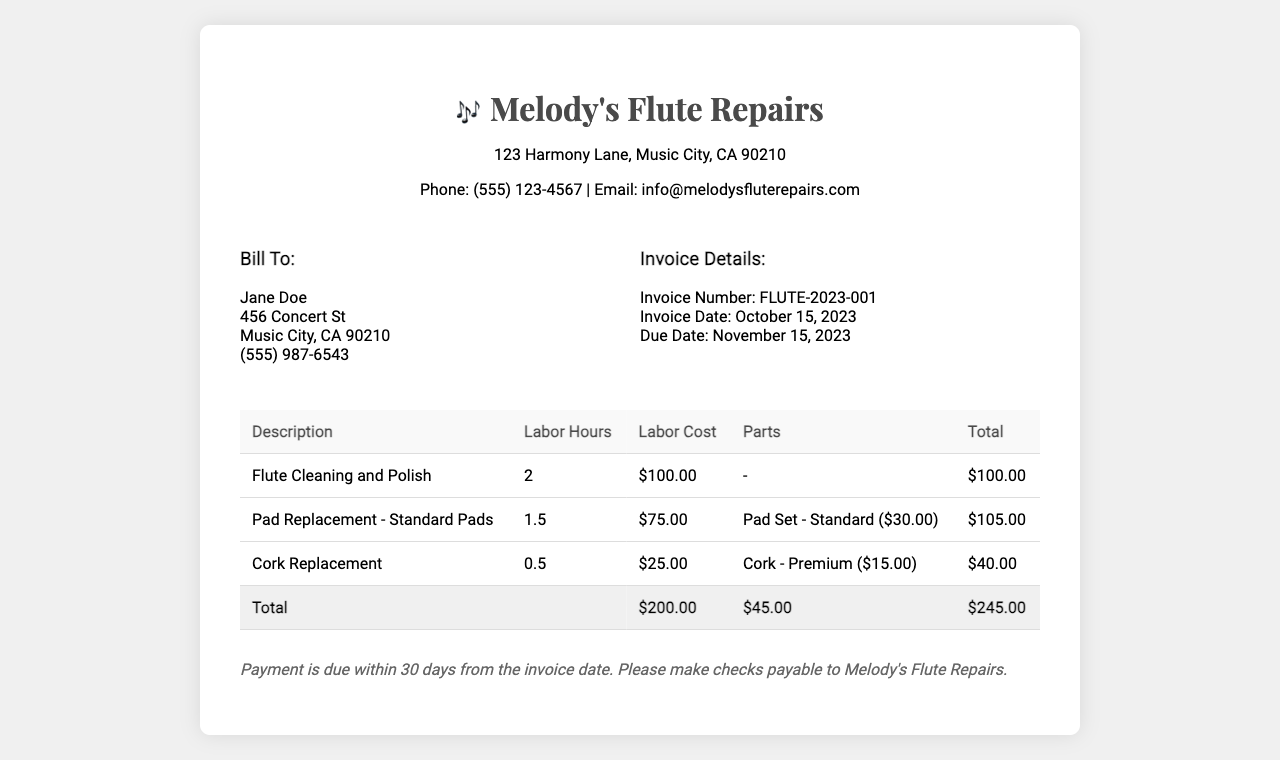what is the invoice number? The invoice number is listed under the invoice details section, which is FLUTE-2023-001.
Answer: FLUTE-2023-001 who is the bill to? The "Bill To" section provides the name of the individual being billed, which is Jane Doe.
Answer: Jane Doe what is the total amount due? The total amount due is summarized in the total row of the table, which is $245.00.
Answer: $245.00 how many labor hours were charged for cork replacement? The labor hours for cork replacement are specifically stated in the table row dedicated to that service, which is 0.5.
Answer: 0.5 when is the payment due? The due date for payment is indicated in the invoice details section, which is November 15, 2023.
Answer: November 15, 2023 what parts were included in the pad replacement? The pad replacement section mentions the specific parts included, which is "Pad Set - Standard ($30.00)".
Answer: Pad Set - Standard ($30.00) how much was charged for labor in total? The total labor cost is the sum of the labor costs in the table, which is $200.00.
Answer: $200.00 what is the address of Melody's Flute Repairs? The address for Melody's Flute Repairs is listed at the top of the invoice, which is 123 Harmony Lane, Music City, CA 90210.
Answer: 123 Harmony Lane, Music City, CA 90210 what is the email address for Melody's Flute Repairs? The contact email for Melody's Flute Repairs is provided in the header of the invoice, which is info@melodysfluterepairs.com.
Answer: info@melodysfluterepairs.com 